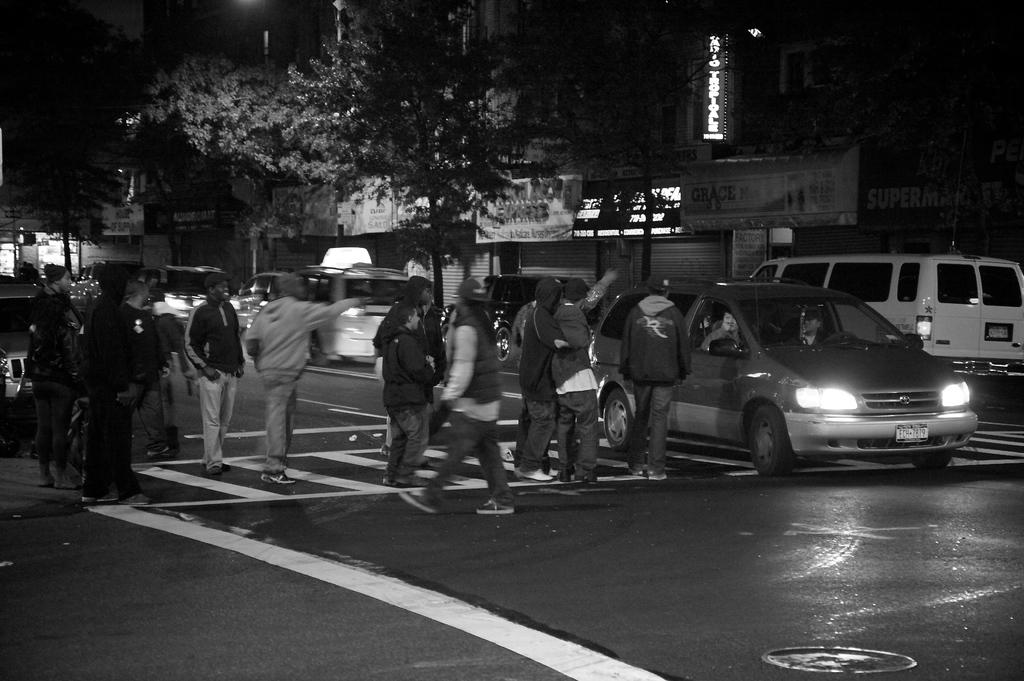How many people are in the image? There is a group of people in the image. What are the people doing in the image? The people are crossing a road. What type of road marking is present in the image? The road has a zebra crossing. Are there any vehicles on the road? Yes, there are cars on the road. What can be seen in the background of the image? There are trees, at least one building, and banners in the background of the image. What is the value of the blood stains on the road in the image? There are no blood stains present in the image. 